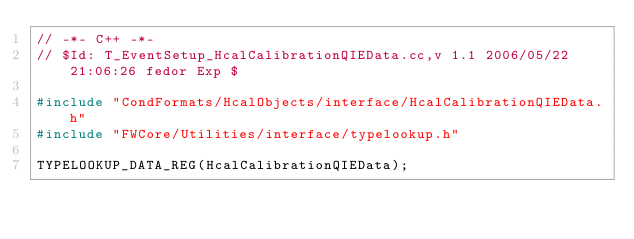<code> <loc_0><loc_0><loc_500><loc_500><_C++_>// -*- C++ -*-
// $Id: T_EventSetup_HcalCalibrationQIEData.cc,v 1.1 2006/05/22 21:06:26 fedor Exp $

#include "CondFormats/HcalObjects/interface/HcalCalibrationQIEData.h"
#include "FWCore/Utilities/interface/typelookup.h"

TYPELOOKUP_DATA_REG(HcalCalibrationQIEData);
</code> 